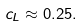<formula> <loc_0><loc_0><loc_500><loc_500>c _ { L } \approx 0 . 2 5 .</formula> 